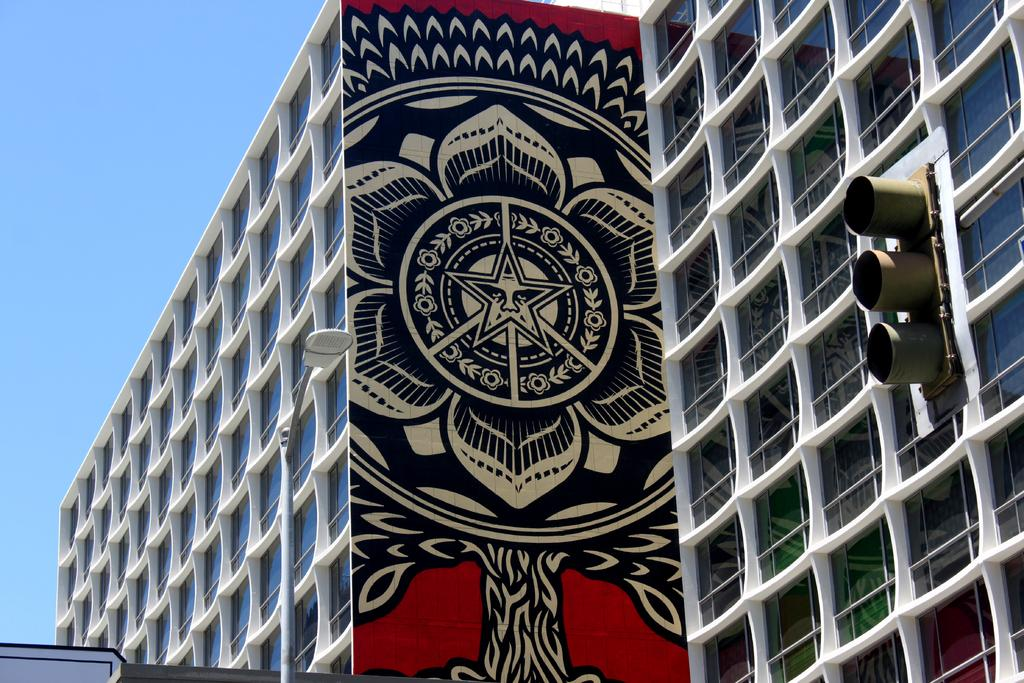What type of structures can be seen on the right side of the image? There are buildings on the right side of the image. What is the tall, vertical object in the image? There is a signal pole in the image. What is the object located in the front of the image? There is a pole in the front of the image. What type of artistic expression can be seen on a wall in the image? There is graffiti on a wall in the image. How does the society depicted in the graffiti feel about the alley in the image? The image does not depict a society, nor does it show an alley. The graffiti is an artistic expression, and it is not possible to determine the feelings or opinions of a society based on the image. 